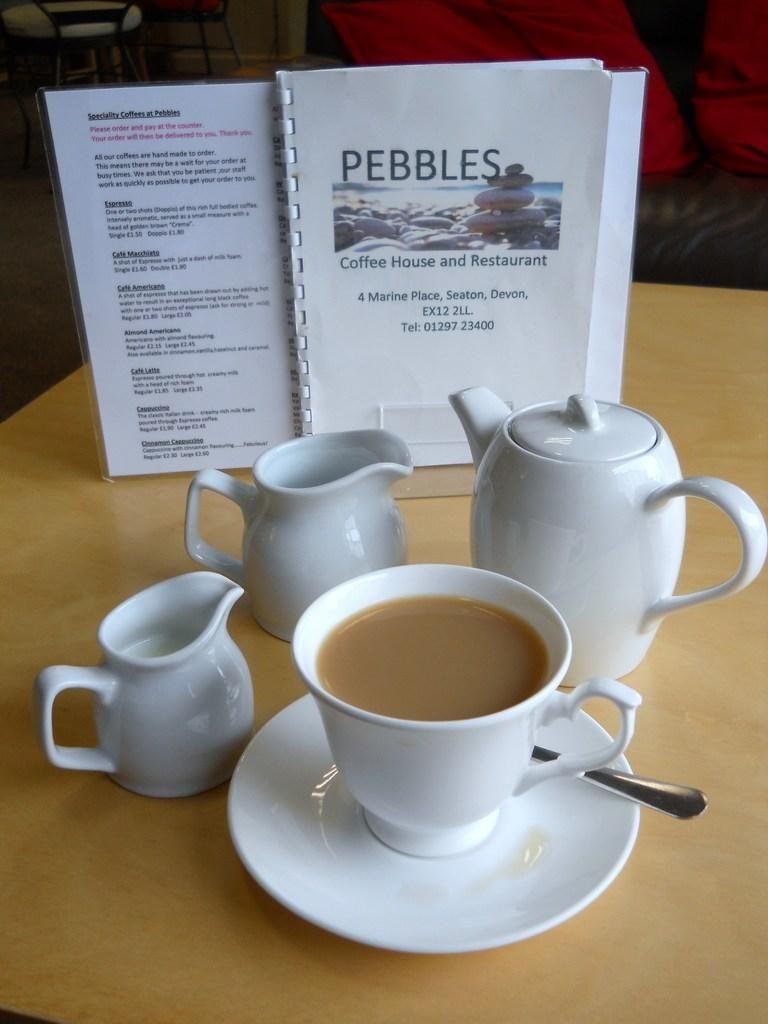What type of container is visible in the image? There is a teapot in the image. What can be used to drink from the teapot? There is a cup in the image that can be used to drink from the teapot. What is typically used to hold the cup when it's not being used? There is a saucer in the image that can be used to hold the cup. What utensil is present in the image? There is a spoon in the image. What is placed on a stand in the image? There are white papers on a stand in the image. What is the color of the surface on which the objects are placed? The objects are on a brown surface. How many babies are sleeping on the wall in the image? There are no babies or walls present in the image. 